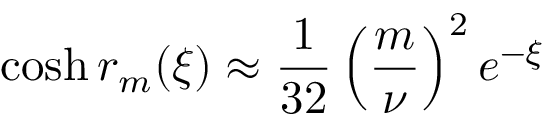Convert formula to latex. <formula><loc_0><loc_0><loc_500><loc_500>\cosh r _ { m } ( \xi ) \approx \frac { 1 } { 3 2 } \left ( \frac { m } { \nu } \right ) ^ { 2 } e ^ { - \xi }</formula> 